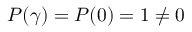Convert formula to latex. <formula><loc_0><loc_0><loc_500><loc_500>P ( \gamma ) = P ( 0 ) = 1 \neq 0</formula> 